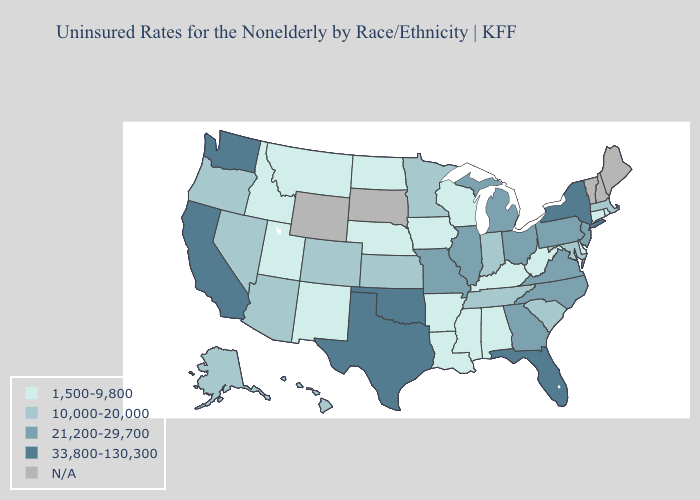Does Georgia have the lowest value in the South?
Write a very short answer. No. Name the states that have a value in the range 21,200-29,700?
Be succinct. Georgia, Illinois, Michigan, Missouri, New Jersey, North Carolina, Ohio, Pennsylvania, Virginia. Which states have the lowest value in the West?
Quick response, please. Idaho, Montana, New Mexico, Utah. Which states have the highest value in the USA?
Quick response, please. California, Florida, New York, Oklahoma, Texas, Washington. Does the first symbol in the legend represent the smallest category?
Be succinct. Yes. Name the states that have a value in the range N/A?
Quick response, please. Maine, New Hampshire, South Dakota, Vermont, Wyoming. Name the states that have a value in the range 33,800-130,300?
Be succinct. California, Florida, New York, Oklahoma, Texas, Washington. Which states have the highest value in the USA?
Write a very short answer. California, Florida, New York, Oklahoma, Texas, Washington. Is the legend a continuous bar?
Write a very short answer. No. Name the states that have a value in the range 1,500-9,800?
Keep it brief. Alabama, Arkansas, Connecticut, Delaware, Idaho, Iowa, Kentucky, Louisiana, Mississippi, Montana, Nebraska, New Mexico, North Dakota, Rhode Island, Utah, West Virginia, Wisconsin. What is the lowest value in states that border North Carolina?
Concise answer only. 10,000-20,000. What is the value of New Mexico?
Be succinct. 1,500-9,800. Does Rhode Island have the lowest value in the Northeast?
Be succinct. Yes. Which states hav the highest value in the MidWest?
Short answer required. Illinois, Michigan, Missouri, Ohio. 